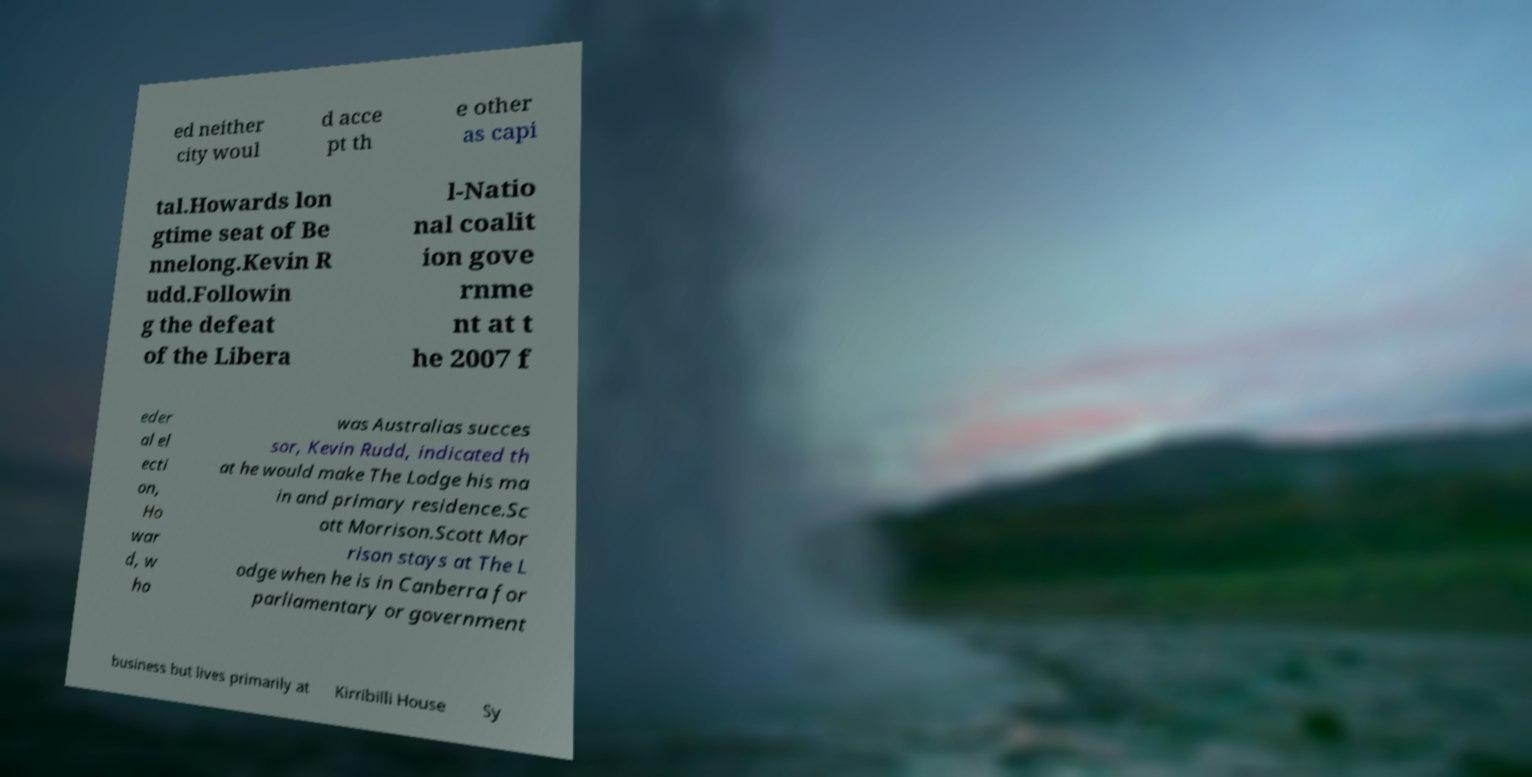Please identify and transcribe the text found in this image. ed neither city woul d acce pt th e other as capi tal.Howards lon gtime seat of Be nnelong.Kevin R udd.Followin g the defeat of the Libera l-Natio nal coalit ion gove rnme nt at t he 2007 f eder al el ecti on, Ho war d, w ho was Australias succes sor, Kevin Rudd, indicated th at he would make The Lodge his ma in and primary residence.Sc ott Morrison.Scott Mor rison stays at The L odge when he is in Canberra for parliamentary or government business but lives primarily at Kirribilli House Sy 